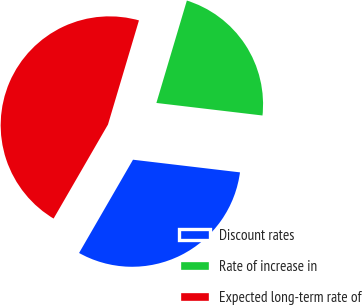Convert chart to OTSL. <chart><loc_0><loc_0><loc_500><loc_500><pie_chart><fcel>Discount rates<fcel>Rate of increase in<fcel>Expected long-term rate of<nl><fcel>31.47%<fcel>22.27%<fcel>46.26%<nl></chart> 